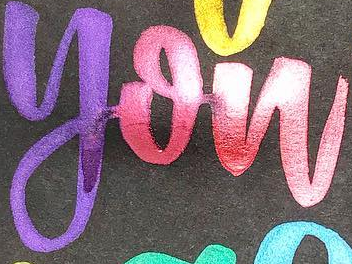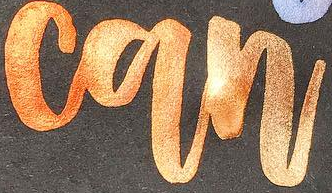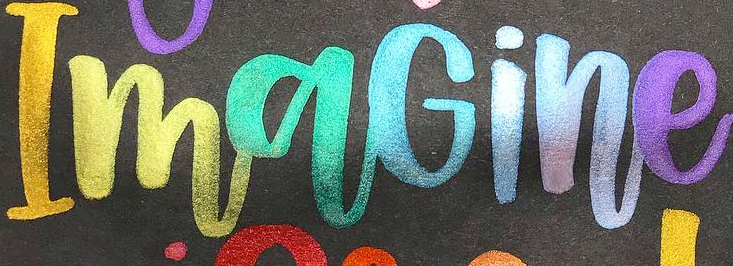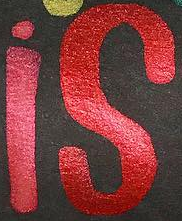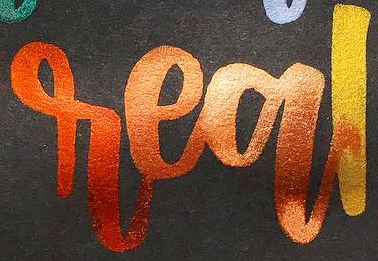Read the text content from these images in order, separated by a semicolon. you; can; ImaGine; is; real 